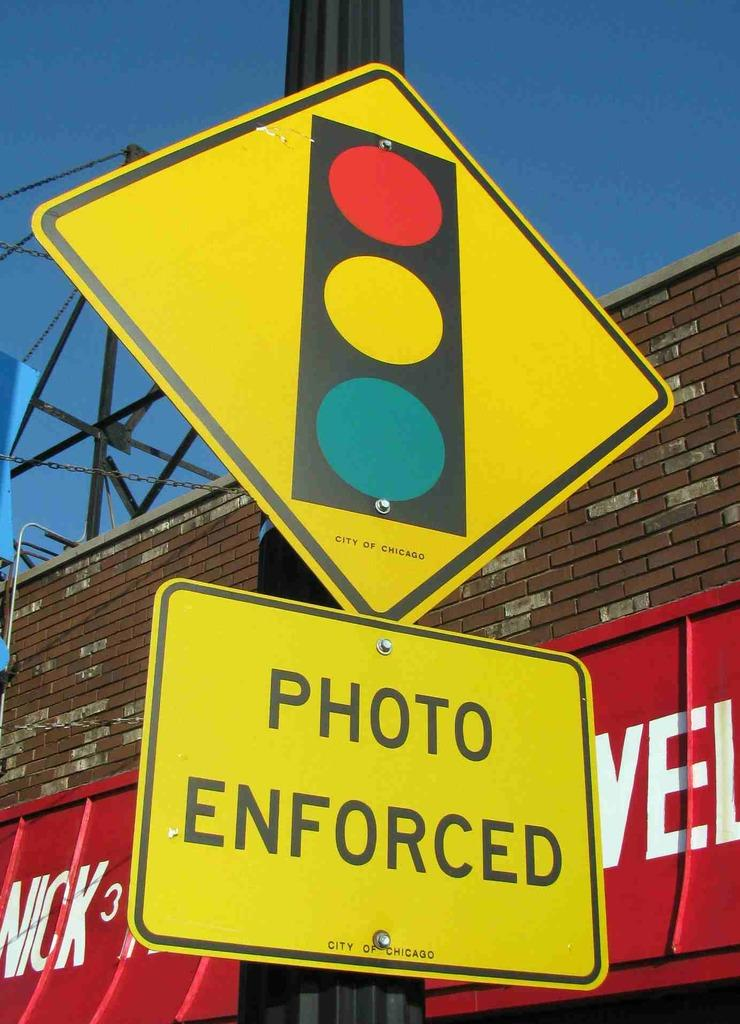<image>
Offer a succinct explanation of the picture presented. Diamond shaped yellow sign that says "Photo Enforced" on the bottom. 